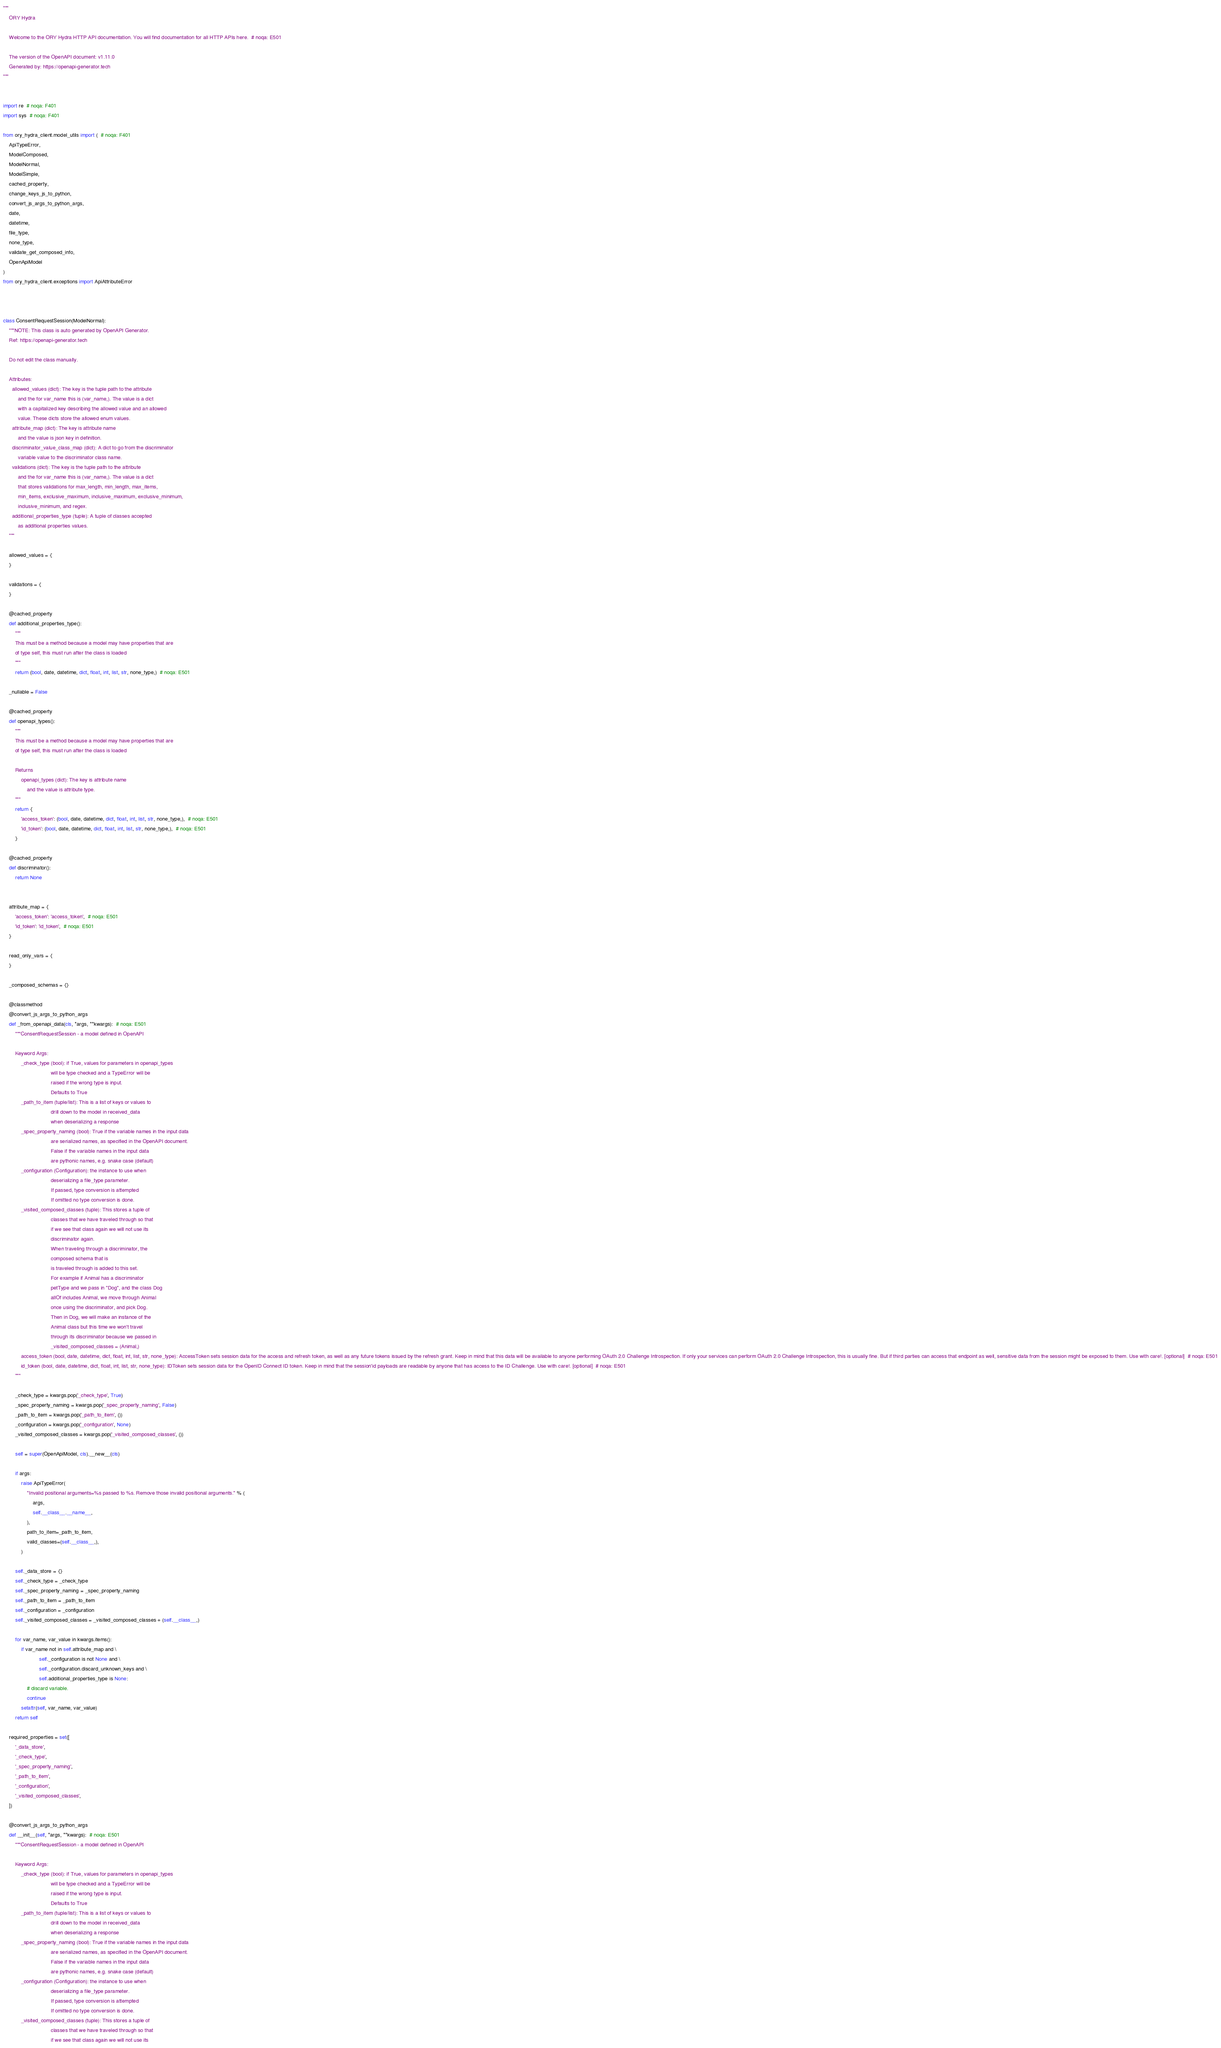<code> <loc_0><loc_0><loc_500><loc_500><_Python_>"""
    ORY Hydra

    Welcome to the ORY Hydra HTTP API documentation. You will find documentation for all HTTP APIs here.  # noqa: E501

    The version of the OpenAPI document: v1.11.0
    Generated by: https://openapi-generator.tech
"""


import re  # noqa: F401
import sys  # noqa: F401

from ory_hydra_client.model_utils import (  # noqa: F401
    ApiTypeError,
    ModelComposed,
    ModelNormal,
    ModelSimple,
    cached_property,
    change_keys_js_to_python,
    convert_js_args_to_python_args,
    date,
    datetime,
    file_type,
    none_type,
    validate_get_composed_info,
    OpenApiModel
)
from ory_hydra_client.exceptions import ApiAttributeError



class ConsentRequestSession(ModelNormal):
    """NOTE: This class is auto generated by OpenAPI Generator.
    Ref: https://openapi-generator.tech

    Do not edit the class manually.

    Attributes:
      allowed_values (dict): The key is the tuple path to the attribute
          and the for var_name this is (var_name,). The value is a dict
          with a capitalized key describing the allowed value and an allowed
          value. These dicts store the allowed enum values.
      attribute_map (dict): The key is attribute name
          and the value is json key in definition.
      discriminator_value_class_map (dict): A dict to go from the discriminator
          variable value to the discriminator class name.
      validations (dict): The key is the tuple path to the attribute
          and the for var_name this is (var_name,). The value is a dict
          that stores validations for max_length, min_length, max_items,
          min_items, exclusive_maximum, inclusive_maximum, exclusive_minimum,
          inclusive_minimum, and regex.
      additional_properties_type (tuple): A tuple of classes accepted
          as additional properties values.
    """

    allowed_values = {
    }

    validations = {
    }

    @cached_property
    def additional_properties_type():
        """
        This must be a method because a model may have properties that are
        of type self, this must run after the class is loaded
        """
        return (bool, date, datetime, dict, float, int, list, str, none_type,)  # noqa: E501

    _nullable = False

    @cached_property
    def openapi_types():
        """
        This must be a method because a model may have properties that are
        of type self, this must run after the class is loaded

        Returns
            openapi_types (dict): The key is attribute name
                and the value is attribute type.
        """
        return {
            'access_token': (bool, date, datetime, dict, float, int, list, str, none_type,),  # noqa: E501
            'id_token': (bool, date, datetime, dict, float, int, list, str, none_type,),  # noqa: E501
        }

    @cached_property
    def discriminator():
        return None


    attribute_map = {
        'access_token': 'access_token',  # noqa: E501
        'id_token': 'id_token',  # noqa: E501
    }

    read_only_vars = {
    }

    _composed_schemas = {}

    @classmethod
    @convert_js_args_to_python_args
    def _from_openapi_data(cls, *args, **kwargs):  # noqa: E501
        """ConsentRequestSession - a model defined in OpenAPI

        Keyword Args:
            _check_type (bool): if True, values for parameters in openapi_types
                                will be type checked and a TypeError will be
                                raised if the wrong type is input.
                                Defaults to True
            _path_to_item (tuple/list): This is a list of keys or values to
                                drill down to the model in received_data
                                when deserializing a response
            _spec_property_naming (bool): True if the variable names in the input data
                                are serialized names, as specified in the OpenAPI document.
                                False if the variable names in the input data
                                are pythonic names, e.g. snake case (default)
            _configuration (Configuration): the instance to use when
                                deserializing a file_type parameter.
                                If passed, type conversion is attempted
                                If omitted no type conversion is done.
            _visited_composed_classes (tuple): This stores a tuple of
                                classes that we have traveled through so that
                                if we see that class again we will not use its
                                discriminator again.
                                When traveling through a discriminator, the
                                composed schema that is
                                is traveled through is added to this set.
                                For example if Animal has a discriminator
                                petType and we pass in "Dog", and the class Dog
                                allOf includes Animal, we move through Animal
                                once using the discriminator, and pick Dog.
                                Then in Dog, we will make an instance of the
                                Animal class but this time we won't travel
                                through its discriminator because we passed in
                                _visited_composed_classes = (Animal,)
            access_token (bool, date, datetime, dict, float, int, list, str, none_type): AccessToken sets session data for the access and refresh token, as well as any future tokens issued by the refresh grant. Keep in mind that this data will be available to anyone performing OAuth 2.0 Challenge Introspection. If only your services can perform OAuth 2.0 Challenge Introspection, this is usually fine. But if third parties can access that endpoint as well, sensitive data from the session might be exposed to them. Use with care!. [optional]  # noqa: E501
            id_token (bool, date, datetime, dict, float, int, list, str, none_type): IDToken sets session data for the OpenID Connect ID token. Keep in mind that the session'id payloads are readable by anyone that has access to the ID Challenge. Use with care!. [optional]  # noqa: E501
        """

        _check_type = kwargs.pop('_check_type', True)
        _spec_property_naming = kwargs.pop('_spec_property_naming', False)
        _path_to_item = kwargs.pop('_path_to_item', ())
        _configuration = kwargs.pop('_configuration', None)
        _visited_composed_classes = kwargs.pop('_visited_composed_classes', ())

        self = super(OpenApiModel, cls).__new__(cls)

        if args:
            raise ApiTypeError(
                "Invalid positional arguments=%s passed to %s. Remove those invalid positional arguments." % (
                    args,
                    self.__class__.__name__,
                ),
                path_to_item=_path_to_item,
                valid_classes=(self.__class__,),
            )

        self._data_store = {}
        self._check_type = _check_type
        self._spec_property_naming = _spec_property_naming
        self._path_to_item = _path_to_item
        self._configuration = _configuration
        self._visited_composed_classes = _visited_composed_classes + (self.__class__,)

        for var_name, var_value in kwargs.items():
            if var_name not in self.attribute_map and \
                        self._configuration is not None and \
                        self._configuration.discard_unknown_keys and \
                        self.additional_properties_type is None:
                # discard variable.
                continue
            setattr(self, var_name, var_value)
        return self

    required_properties = set([
        '_data_store',
        '_check_type',
        '_spec_property_naming',
        '_path_to_item',
        '_configuration',
        '_visited_composed_classes',
    ])

    @convert_js_args_to_python_args
    def __init__(self, *args, **kwargs):  # noqa: E501
        """ConsentRequestSession - a model defined in OpenAPI

        Keyword Args:
            _check_type (bool): if True, values for parameters in openapi_types
                                will be type checked and a TypeError will be
                                raised if the wrong type is input.
                                Defaults to True
            _path_to_item (tuple/list): This is a list of keys or values to
                                drill down to the model in received_data
                                when deserializing a response
            _spec_property_naming (bool): True if the variable names in the input data
                                are serialized names, as specified in the OpenAPI document.
                                False if the variable names in the input data
                                are pythonic names, e.g. snake case (default)
            _configuration (Configuration): the instance to use when
                                deserializing a file_type parameter.
                                If passed, type conversion is attempted
                                If omitted no type conversion is done.
            _visited_composed_classes (tuple): This stores a tuple of
                                classes that we have traveled through so that
                                if we see that class again we will not use its</code> 